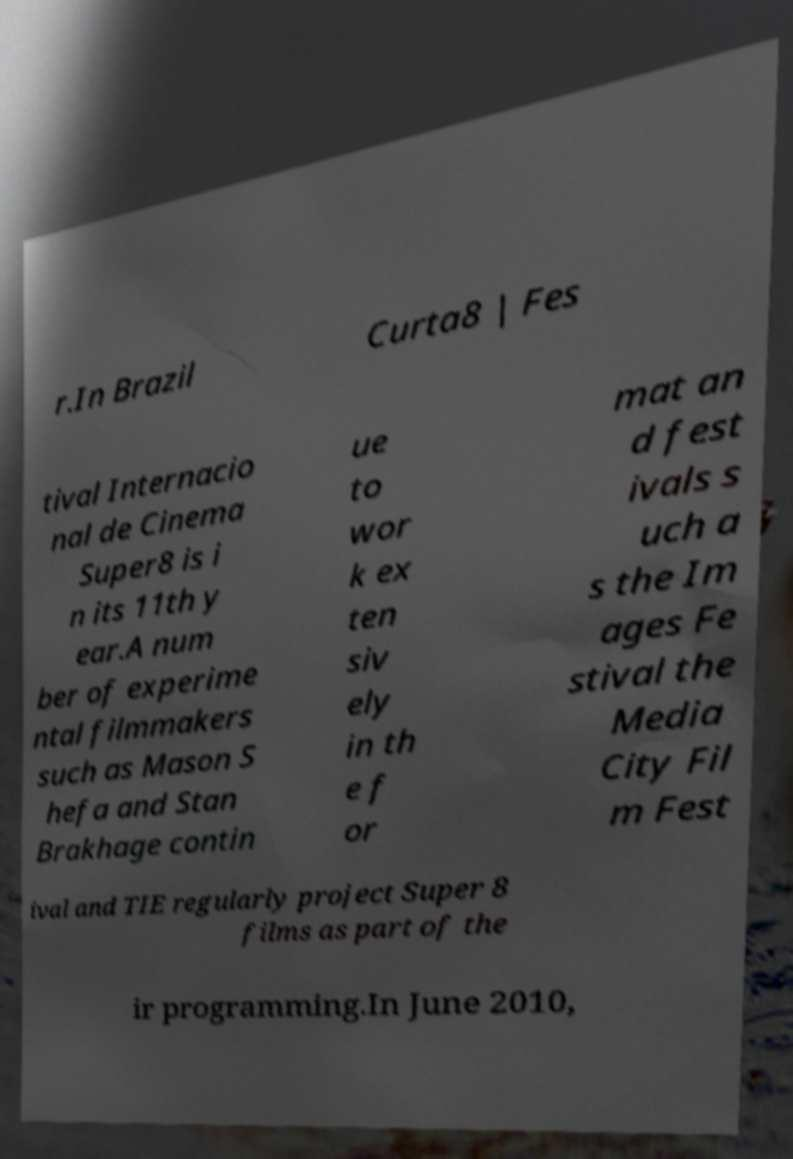Could you assist in decoding the text presented in this image and type it out clearly? r.In Brazil Curta8 | Fes tival Internacio nal de Cinema Super8 is i n its 11th y ear.A num ber of experime ntal filmmakers such as Mason S hefa and Stan Brakhage contin ue to wor k ex ten siv ely in th e f or mat an d fest ivals s uch a s the Im ages Fe stival the Media City Fil m Fest ival and TIE regularly project Super 8 films as part of the ir programming.In June 2010, 